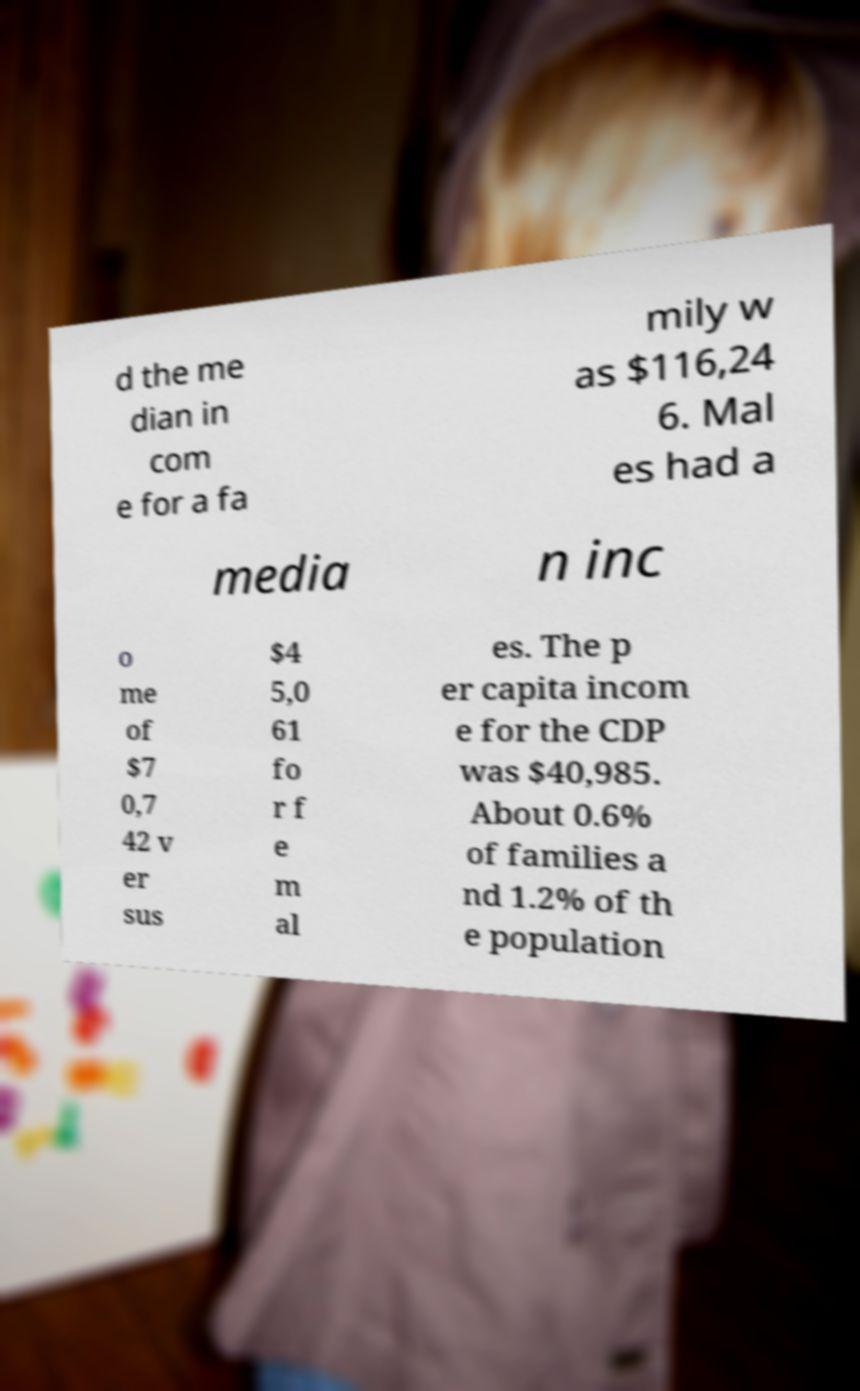Could you assist in decoding the text presented in this image and type it out clearly? d the me dian in com e for a fa mily w as $116,24 6. Mal es had a media n inc o me of $7 0,7 42 v er sus $4 5,0 61 fo r f e m al es. The p er capita incom e for the CDP was $40,985. About 0.6% of families a nd 1.2% of th e population 